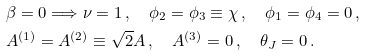Convert formula to latex. <formula><loc_0><loc_0><loc_500><loc_500>& \beta = 0 \Longrightarrow \nu = 1 \, , \quad \phi _ { 2 } = \phi _ { 3 } \equiv \chi \, , \quad \phi _ { 1 } = \phi _ { 4 } = 0 \, , \\ & A ^ { ( 1 ) } = A ^ { ( 2 ) } \equiv \sqrt { 2 } A \, , \quad A ^ { ( 3 ) } = 0 \, , \quad \theta _ { J } = 0 \, .</formula> 